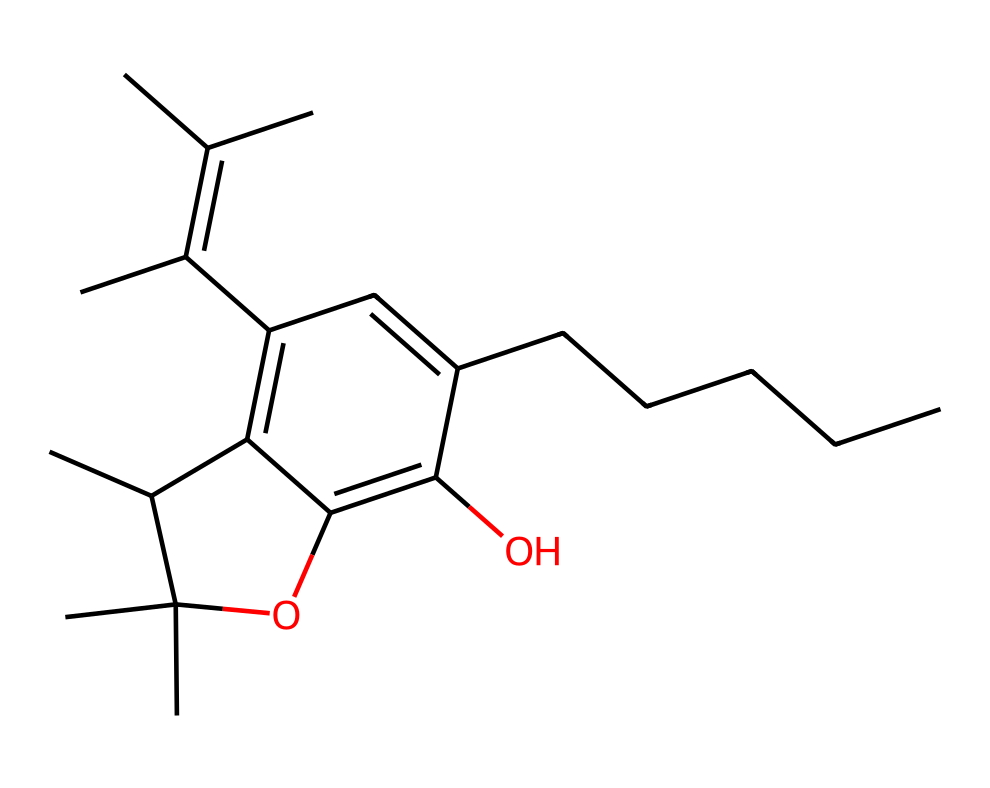What is the molecular formula of THC? To derive the molecular formula from the provided SMILES, we need to count the number of each type of atom represented. The SMILES indicates carbon (C), hydrogen (H), and oxygen (O) atoms. Counting 21 carbons, 30 hydrogens, and 2 oxygens gives us C21H30O2.
Answer: C21H30O2 How many oxygen atoms are present in THC? Looking at the molecular structure via the SMILES representation, we can identify the presence of two oxygen atoms (denoted by the 'O').
Answer: 2 What type of functional groups are present in THC? The structure features a phenolic group (due to the presence of the -OH group) and an ether (due to the -O- bridging two carbons). Identification of these groups can be made by examining the arrangement around the oxygen atoms.
Answer: phenol and ether Does THC have any double bonds? By analyzing the structure represented in the SMILES notation, we can observe areas between carbon atoms where double bonds exist (noted by the equal signs present in the structure). This confirms the presence of double bonds in the molecule.
Answer: yes What is the degree of unsaturation in THC? The degree of unsaturation can be calculated by the formula (2C + 2 + N - H - X)/2. Substituting in the values for THC, we find the degree of unsaturation indicates the presence of rings or double bonds, concluding the presence of multiple unsaturated features.
Answer: 7 What is the significance of the hydroxyl (-OH) group in THC? The hydroxyl group contributes to the compound's solubility in water and affects its interaction with biological systems. This functional group's placement in the molecule further implicates THC's psychoactive properties owing to its polar characteristics.
Answer: solubility and psychoactivity 